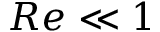Convert formula to latex. <formula><loc_0><loc_0><loc_500><loc_500>R e \ll 1</formula> 